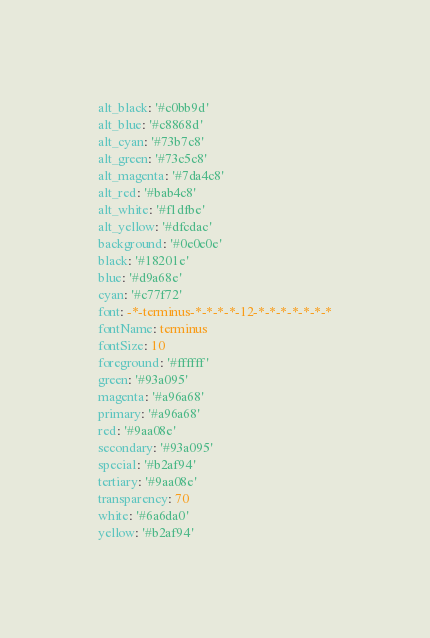<code> <loc_0><loc_0><loc_500><loc_500><_YAML_>alt_black: '#c0bb9d'
alt_blue: '#c8868d'
alt_cyan: '#73b7c8'
alt_green: '#73c5c8'
alt_magenta: '#7da4c8'
alt_red: '#bab4c8'
alt_white: '#f1dfbe'
alt_yellow: '#dfcdac'
background: '#0e0e0e'
black: '#18201e'
blue: '#d9a68e'
cyan: '#c77f72'
font: -*-terminus-*-*-*-*-12-*-*-*-*-*-*-*
fontName: terminus
fontSize: 10
foreground: '#ffffff'
green: '#93a095'
magenta: '#a96a68'
primary: '#a96a68'
red: '#9aa08e'
secondary: '#93a095'
special: '#b2af94'
tertiary: '#9aa08e'
transparency: 70
white: '#6a6da0'
yellow: '#b2af94'
</code> 